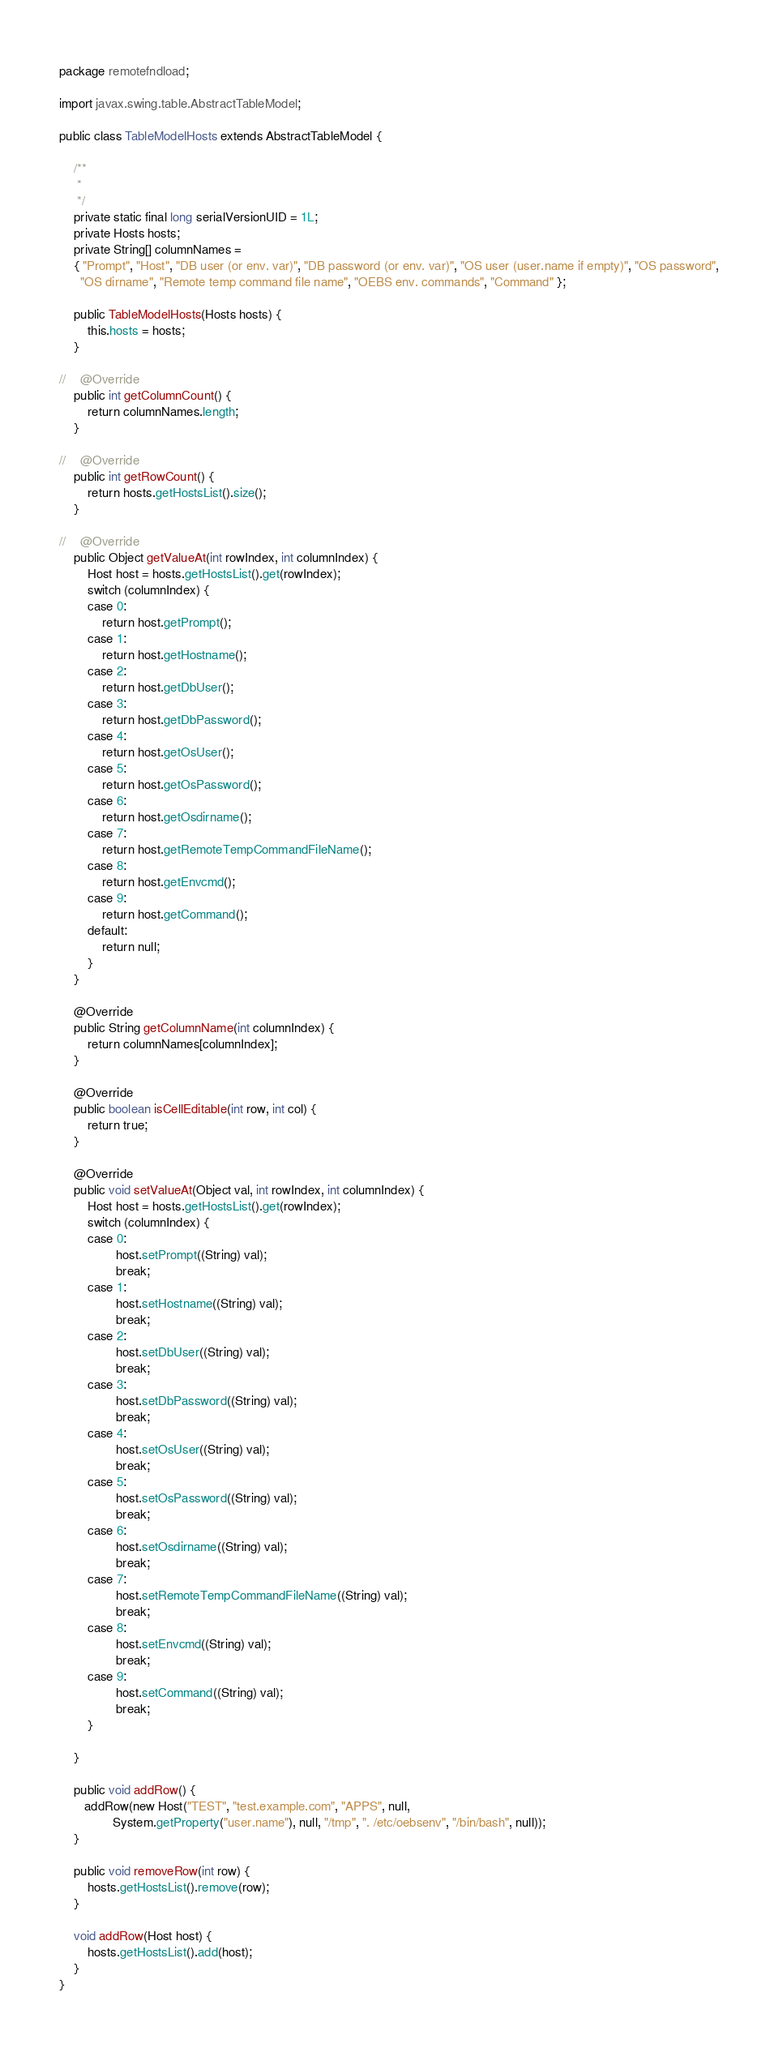<code> <loc_0><loc_0><loc_500><loc_500><_Java_>package remotefndload;

import javax.swing.table.AbstractTableModel;

public class TableModelHosts extends AbstractTableModel {

    /**
     *
     */
    private static final long serialVersionUID = 1L;
    private Hosts hosts;
    private String[] columnNames =
    { "Prompt", "Host", "DB user (or env. var)", "DB password (or env. var)", "OS user (user.name if empty)", "OS password",
      "OS dirname", "Remote temp command file name", "OEBS env. commands", "Command" };

    public TableModelHosts(Hosts hosts) {
        this.hosts = hosts;
    }

//    @Override
    public int getColumnCount() {
        return columnNames.length;
    }

//    @Override
    public int getRowCount() {
        return hosts.getHostsList().size();
    }

//    @Override
    public Object getValueAt(int rowIndex, int columnIndex) {
        Host host = hosts.getHostsList().get(rowIndex);
        switch (columnIndex) {
        case 0:
            return host.getPrompt();
        case 1:
            return host.getHostname();
        case 2:
            return host.getDbUser();
        case 3:
            return host.getDbPassword();
        case 4:
            return host.getOsUser();
        case 5:
            return host.getOsPassword();
        case 6:
            return host.getOsdirname();
        case 7:
            return host.getRemoteTempCommandFileName();
        case 8:
            return host.getEnvcmd();
        case 9:
            return host.getCommand();
        default:
            return null;
        }
    }

    @Override
    public String getColumnName(int columnIndex) {
        return columnNames[columnIndex];
    }

    @Override
    public boolean isCellEditable(int row, int col) {
        return true;
    }

    @Override
    public void setValueAt(Object val, int rowIndex, int columnIndex) {
        Host host = hosts.getHostsList().get(rowIndex);
        switch (columnIndex) {
        case 0:
                host.setPrompt((String) val);
                break;
        case 1:
                host.setHostname((String) val);
                break;
        case 2:
                host.setDbUser((String) val);
                break;
        case 3:
                host.setDbPassword((String) val);
                break;
        case 4:
                host.setOsUser((String) val);
                break;
        case 5:
                host.setOsPassword((String) val);
                break;
        case 6:
                host.setOsdirname((String) val);
                break;
        case 7:
                host.setRemoteTempCommandFileName((String) val);
                break;
        case 8:
                host.setEnvcmd((String) val);
                break;
        case 9:
                host.setCommand((String) val);
                break;
        }

    }

    public void addRow() {
       addRow(new Host("TEST", "test.example.com", "APPS", null,
               System.getProperty("user.name"), null, "/tmp", ". /etc/oebsenv", "/bin/bash", null));
    }

    public void removeRow(int row) {
        hosts.getHostsList().remove(row);
    }

    void addRow(Host host) {
        hosts.getHostsList().add(host);
    }
}
</code> 